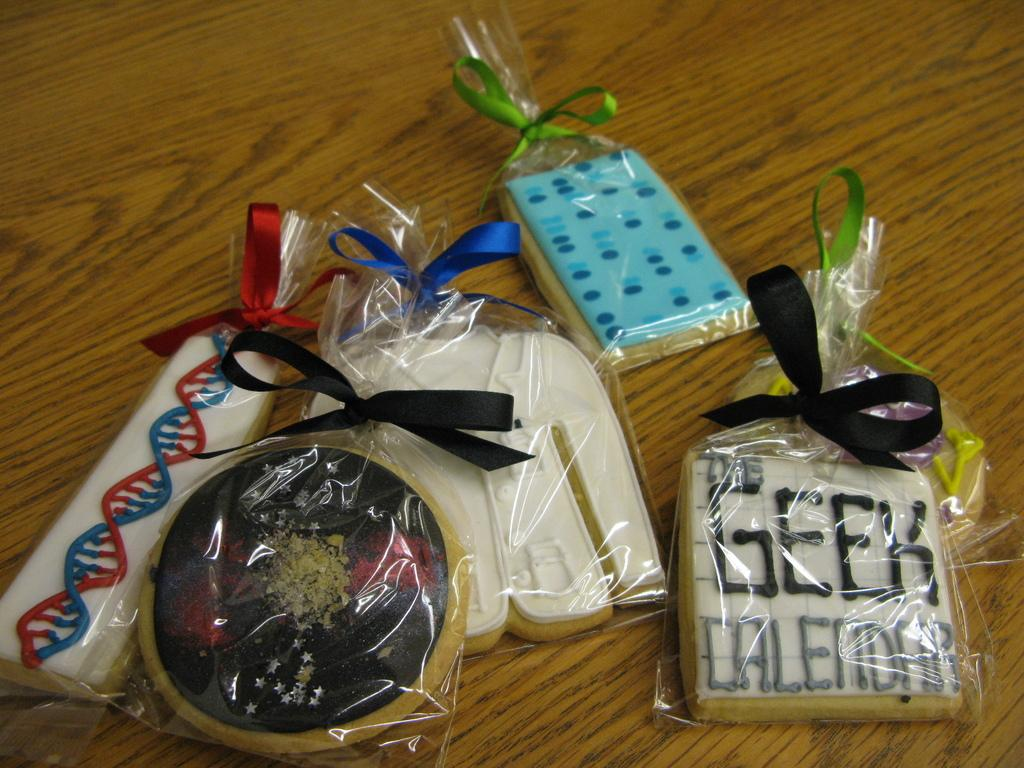What is the main subject of the image? The main subject of the image is items on a table. Can you describe the appearance of the items on the table? The items have different shapes and sizes. How many babies are present on the table in the image? There are no babies present on the table in the image. What type of attack is being carried out on the items in the image? There is no attack present in the image; it simply shows items on a table. 